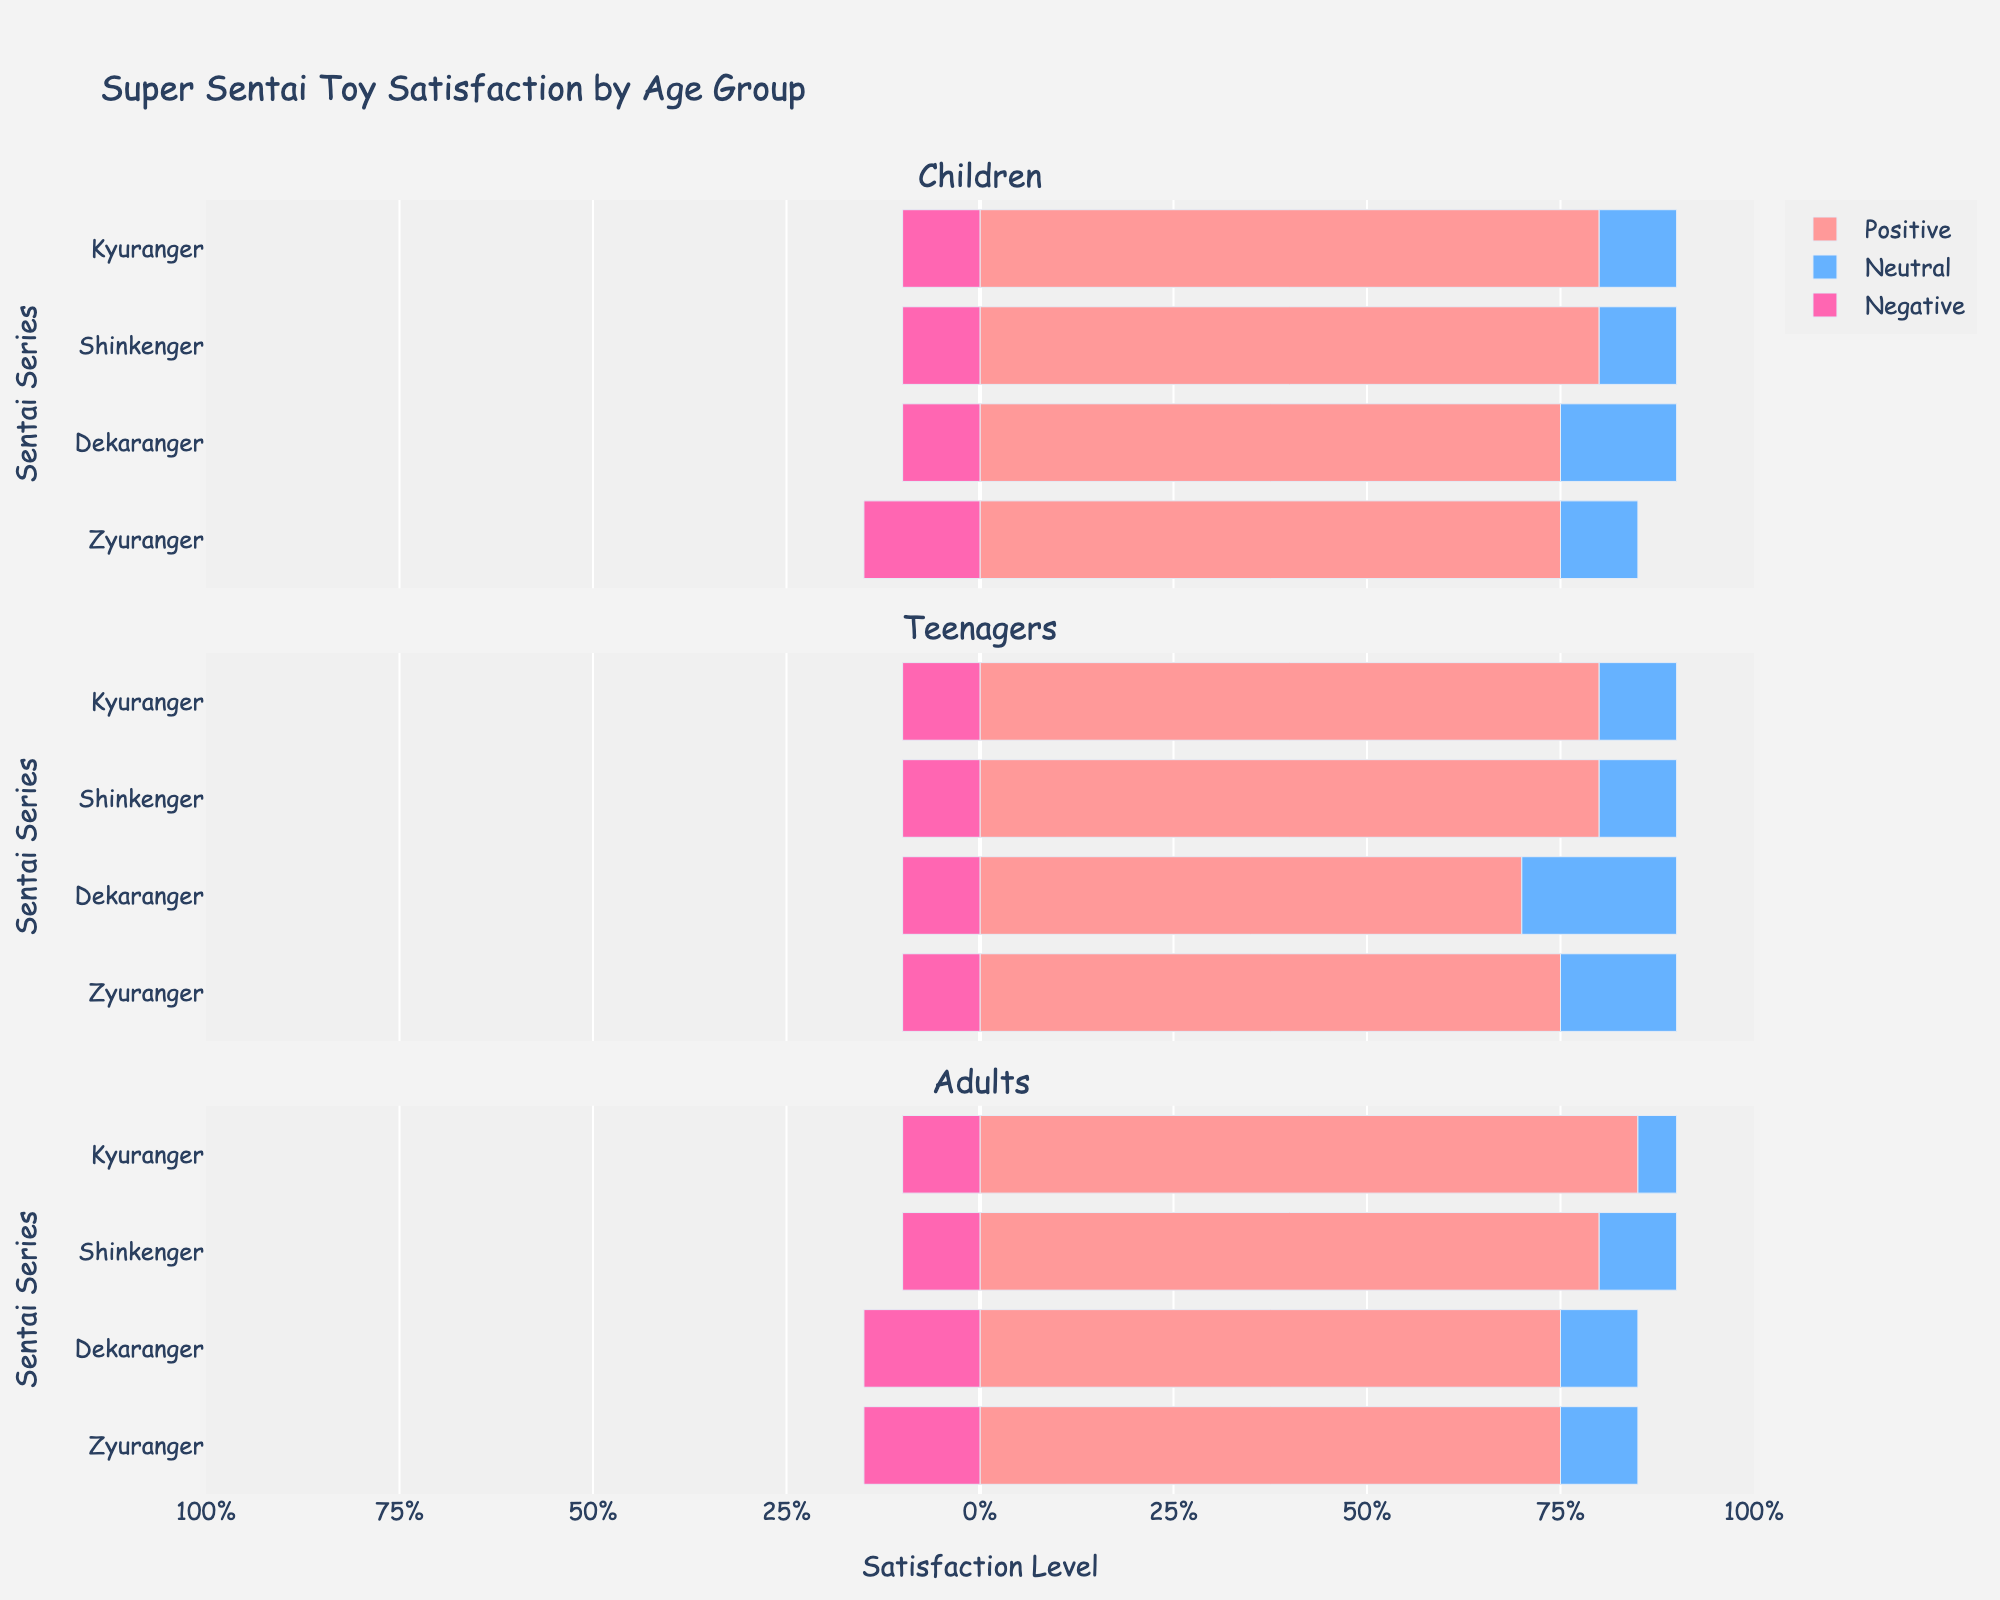Which age group has the most positive satisfaction with Kyuranger? The positive satisfaction includes 'Very Satisfied' and 'Satisfied'. For Kyuranger, children have 55+25=80, teenagers have 50+30=80, and adults have 65+20=85. Therefore, adults have the most positive satisfaction with Kyuranger.
Answer: Adults How does the level of neutral satisfaction with Dekaranger compare across age groups? Looking at Dekaranger, children have a neutral satisfaction of 15, teenagers have 20, and adults have 10. The level of neutral satisfaction is highest for teenagers, followed by children, and lowest for adults.
Answer: Teenagers > Children > Adults Which Sentai series has the highest level of "Very Satisfied" responses from children? For children, Zyuranger has 45, Dekaranger has 50, Shinkenger has 60, and Kyuranger has 55 "Very Satisfied" responses. Therefore, Shinkenger has the highest level of "Very Satisfied" responses from children.
Answer: Shinkenger What is the combined negative satisfaction (Dissatisfied and Very Dissatisfied) for adults with Zyuranger? For adults with Zyuranger, the dissatisfied counts are 10 and very dissatisfied counts are 5. Combined, they make 10+5=15.
Answer: 15 Is the neutral satisfaction level for Shinkenger significantly different between teenagers and adults? Neutral satisfaction for Shinkenger is 10 for both teenagers and adults, which means there’s no difference. Therefore, it’s not significantly different.
Answer: No, it's the same What is the average positive satisfaction across all Sentai series for teenagers? For teenagers:
- Zyuranger: 35+40=75
- Dekaranger: 40+30=70
- Shinkenger: 45+35=80
- Kyuranger: 50+30=80
Average positive satisfaction is (75+70+80+80)/4 = 305/4 = 76.25
Answer: 76.25 Which Sentai series has the highest negative satisfaction from adults and how much is it? For adults, the negative satisfaction is:
- Zyuranger: 10+5=15
- Dekaranger: 10+5=15
- Shinkenger: 5+5=10
- Kyuranger: 5+5=10
Both Zyuranger and Dekaranger have the highest negative satisfaction, which is 15 each.
Answer: Zyuranger and Dekaranger, 15 What is the difference in positive satisfaction between Shinkenger and Dekaranger among children? For children, Shinkenger has 60+20=80 positive satisfaction and Dekaranger has 50+25=75. The difference is 80-75=5.
Answer: 5 How does the combined negative satisfaction of teenagers with Kyuranger compare to that of adults with the same series? For teenagers with Kyuranger, the negative satisfaction is 5+5=10. For adults with Kyuranger, it is also 5+5=10. Thus, they are the same.
Answer: They are the same Which Sentai series has generally the highest satisfaction (Very Satisfied + Satisfied) across all age groups? We compare the sums of 'Very Satisfied' and 'Satisfied' across all age groups:
- Zyuranger: Children (75), Teenagers (75), Adults (75) → Avg = 75
- Dekaranger: Children (75), Teenagers (70), Adults (75) → Avg = 73.33
- Shinkenger: Children (80), Teenagers (80), Adults (80) → Avg = 80
- Kyuranger: Children (80), Teenagers (80), Adults (85) → Avg = 81.67
Kyuranger has the highest average satisfaction across all age groups.
Answer: Kyuranger 